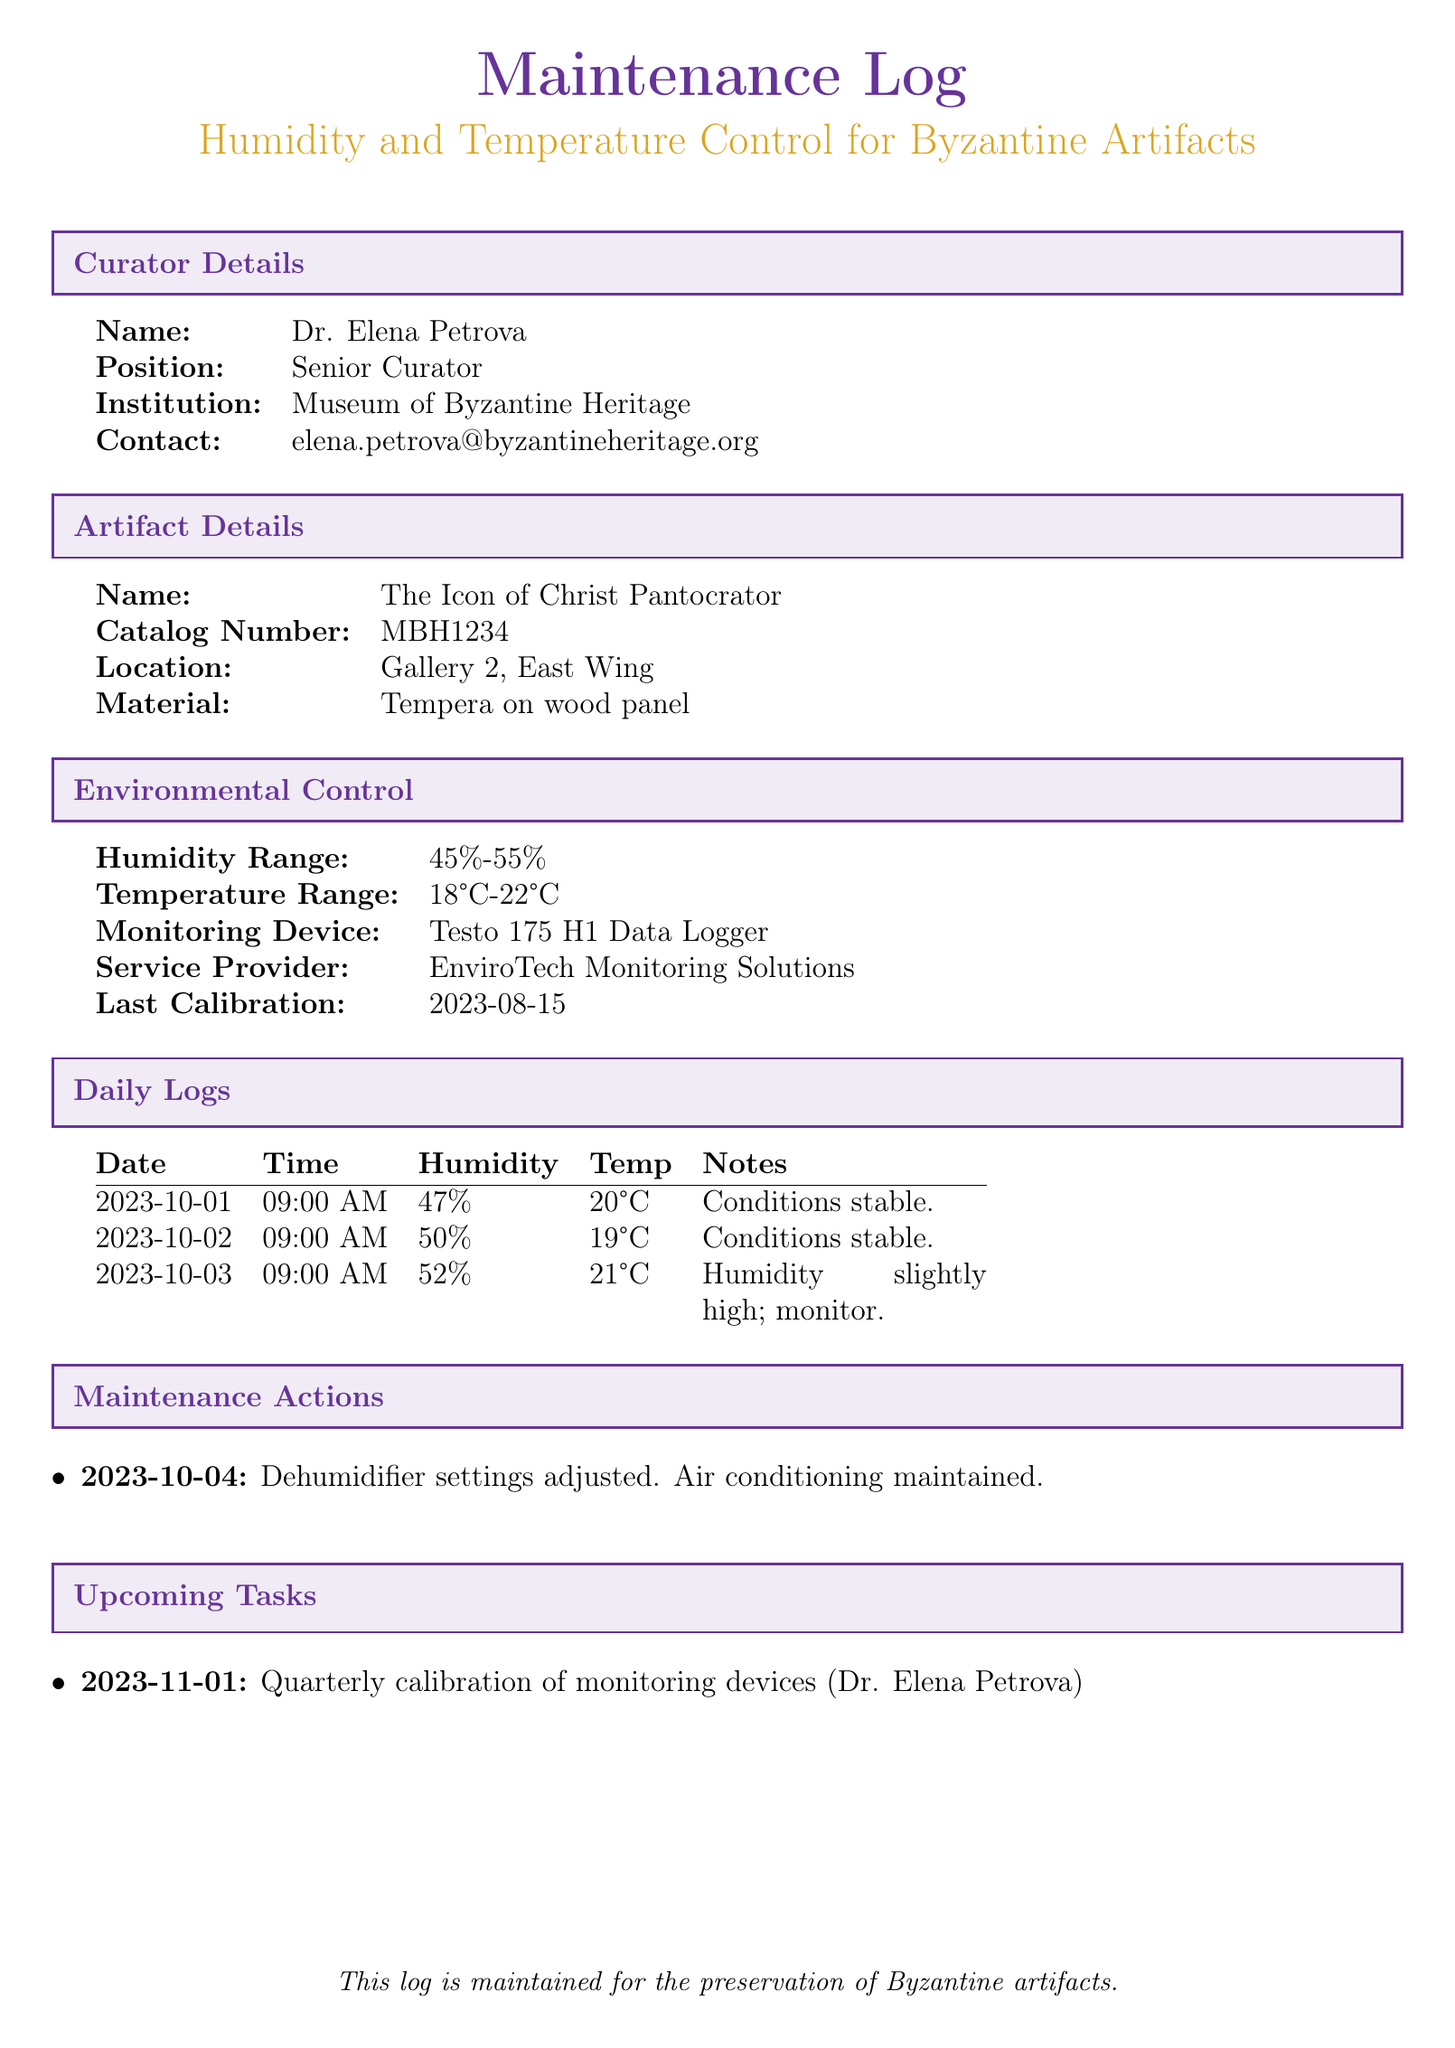what is the name of the artifact? The artifact's name is specified in the document under "Artifact Details" section.
Answer: The Icon of Christ Pantocrator what is the catalog number of the artifact? The catalog number can be found in the "Artifact Details" section of the document.
Answer: MBH1234 what is the humidity range for preservation? The humidity range is stated in the "Environmental Control" section of the document.
Answer: 45%-55% who is the curator? The curator's name is listed under the "Curator Details" section in the document.
Answer: Dr. Elena Petrova what was the humidity on 2023-10-03? The humidity for this date is recorded in the "Daily Logs" section.
Answer: 52% why was the humidity noted as slightly high on 2023-10-03? This information can be inferred from the notes section of the daily log for that date.
Answer: Monitor what is the next scheduled task? The upcoming task is detailed in the "Upcoming Tasks" section of the document.
Answer: Quarterly calibration of monitoring devices when was the last calibration of the monitoring device? The last calibration date is provided in the "Environmental Control" section.
Answer: 2023-08-15 what action was taken on 2023-10-04? The maintenance action is recorded in the "Maintenance Actions" section of the document.
Answer: Dehumidifier settings adjusted 